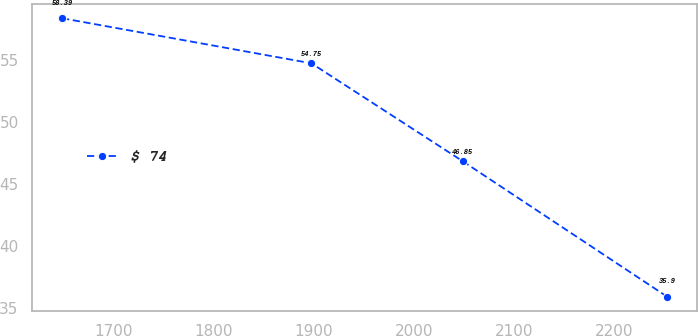Convert chart. <chart><loc_0><loc_0><loc_500><loc_500><line_chart><ecel><fcel>$ 74<nl><fcel>1648.13<fcel>58.39<nl><fcel>1897.43<fcel>54.75<nl><fcel>2048.57<fcel>46.85<nl><fcel>2253.16<fcel>35.9<nl></chart> 